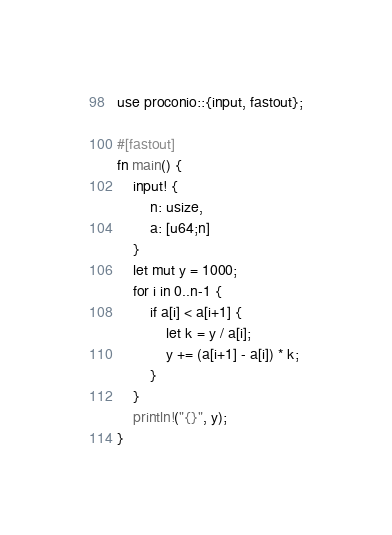<code> <loc_0><loc_0><loc_500><loc_500><_Rust_>use proconio::{input, fastout};

#[fastout]
fn main() {
    input! {
        n: usize,
        a: [u64;n]
    }
    let mut y = 1000;
    for i in 0..n-1 {
        if a[i] < a[i+1] {
            let k = y / a[i];
            y += (a[i+1] - a[i]) * k;
        }
    }
    println!("{}", y);
}
</code> 